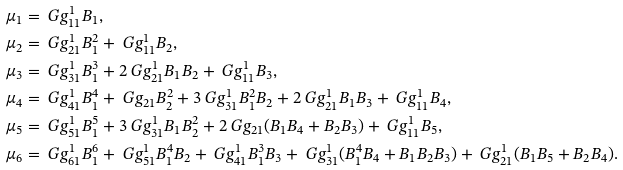<formula> <loc_0><loc_0><loc_500><loc_500>\mu _ { 1 } & = \ G g _ { 1 1 } ^ { 1 } B _ { 1 } , \\ \mu _ { 2 } & = \ G g _ { 2 1 } ^ { 1 } B _ { 1 } ^ { 2 } + \ G g _ { 1 1 } ^ { 1 } B _ { 2 } , \\ \mu _ { 3 } & = \ G g _ { 3 1 } ^ { 1 } B _ { 1 } ^ { 3 } + 2 \ G g _ { 2 1 } ^ { 1 } B _ { 1 } B _ { 2 } + \ G g _ { 1 1 } ^ { 1 } B _ { 3 } , \\ \mu _ { 4 } & = \ G g _ { 4 1 } ^ { 1 } B _ { 1 } ^ { 4 } + \ G g _ { 2 1 } B _ { 2 } ^ { 2 } + 3 \ G g _ { 3 1 } ^ { 1 } B _ { 1 } ^ { 2 } B _ { 2 } + 2 \ G g _ { 2 1 } ^ { 1 } B _ { 1 } B _ { 3 } + \ G g _ { 1 1 } ^ { 1 } B _ { 4 } , \\ \mu _ { 5 } & = \ G g _ { 5 1 } ^ { 1 } B _ { 1 } ^ { 5 } + 3 \ G g _ { 3 1 } ^ { 1 } B _ { 1 } B _ { 2 } ^ { 2 } + 2 \ G g _ { 2 1 } ( B _ { 1 } B _ { 4 } + B _ { 2 } B _ { 3 } ) + \ G g _ { 1 1 } ^ { 1 } B _ { 5 } , \\ \mu _ { 6 } & = \ G g _ { 6 1 } ^ { 1 } B _ { 1 } ^ { 6 } + \ G g _ { 5 1 } ^ { 1 } B _ { 1 } ^ { 4 } B _ { 2 } + \ G g _ { 4 1 } ^ { 1 } B _ { 1 } ^ { 3 } B _ { 3 } + \ G g _ { 3 1 } ^ { 1 } ( B _ { 1 } ^ { 4 } B _ { 4 } + B _ { 1 } B _ { 2 } B _ { 3 } ) + \ G g _ { 2 1 } ^ { 1 } ( B _ { 1 } B _ { 5 } + B _ { 2 } B _ { 4 } ) .</formula> 